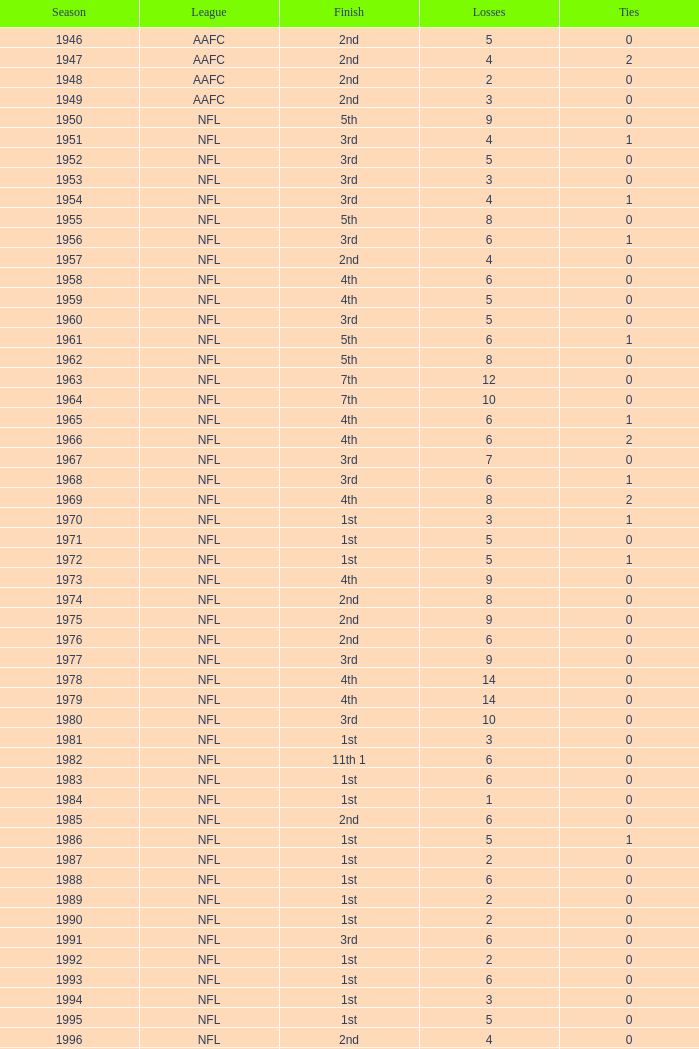What is the number of losses when the ties are lesser than 0? 0.0. 